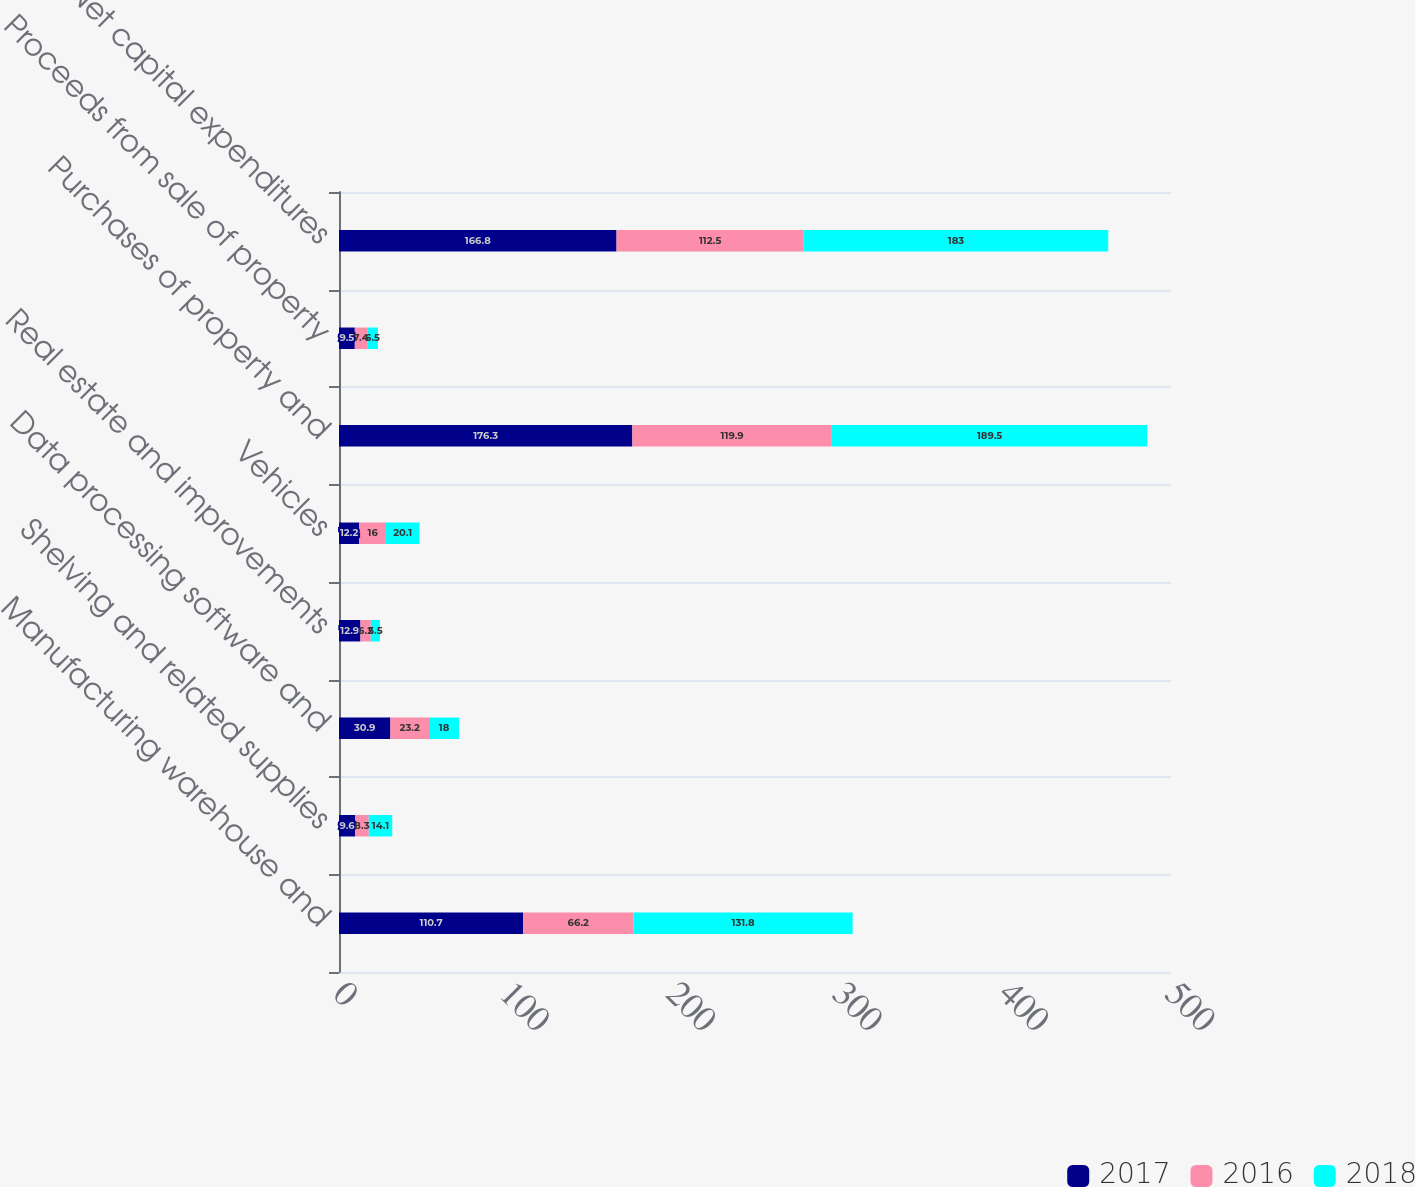Convert chart. <chart><loc_0><loc_0><loc_500><loc_500><stacked_bar_chart><ecel><fcel>Manufacturing warehouse and<fcel>Shelving and related supplies<fcel>Data processing software and<fcel>Real estate and improvements<fcel>Vehicles<fcel>Purchases of property and<fcel>Proceeds from sale of property<fcel>Net capital expenditures<nl><fcel>2017<fcel>110.7<fcel>9.6<fcel>30.9<fcel>12.9<fcel>12.2<fcel>176.3<fcel>9.5<fcel>166.8<nl><fcel>2016<fcel>66.2<fcel>8.3<fcel>23.2<fcel>6.2<fcel>16<fcel>119.9<fcel>7.4<fcel>112.5<nl><fcel>2018<fcel>131.8<fcel>14.1<fcel>18<fcel>5.5<fcel>20.1<fcel>189.5<fcel>6.5<fcel>183<nl></chart> 